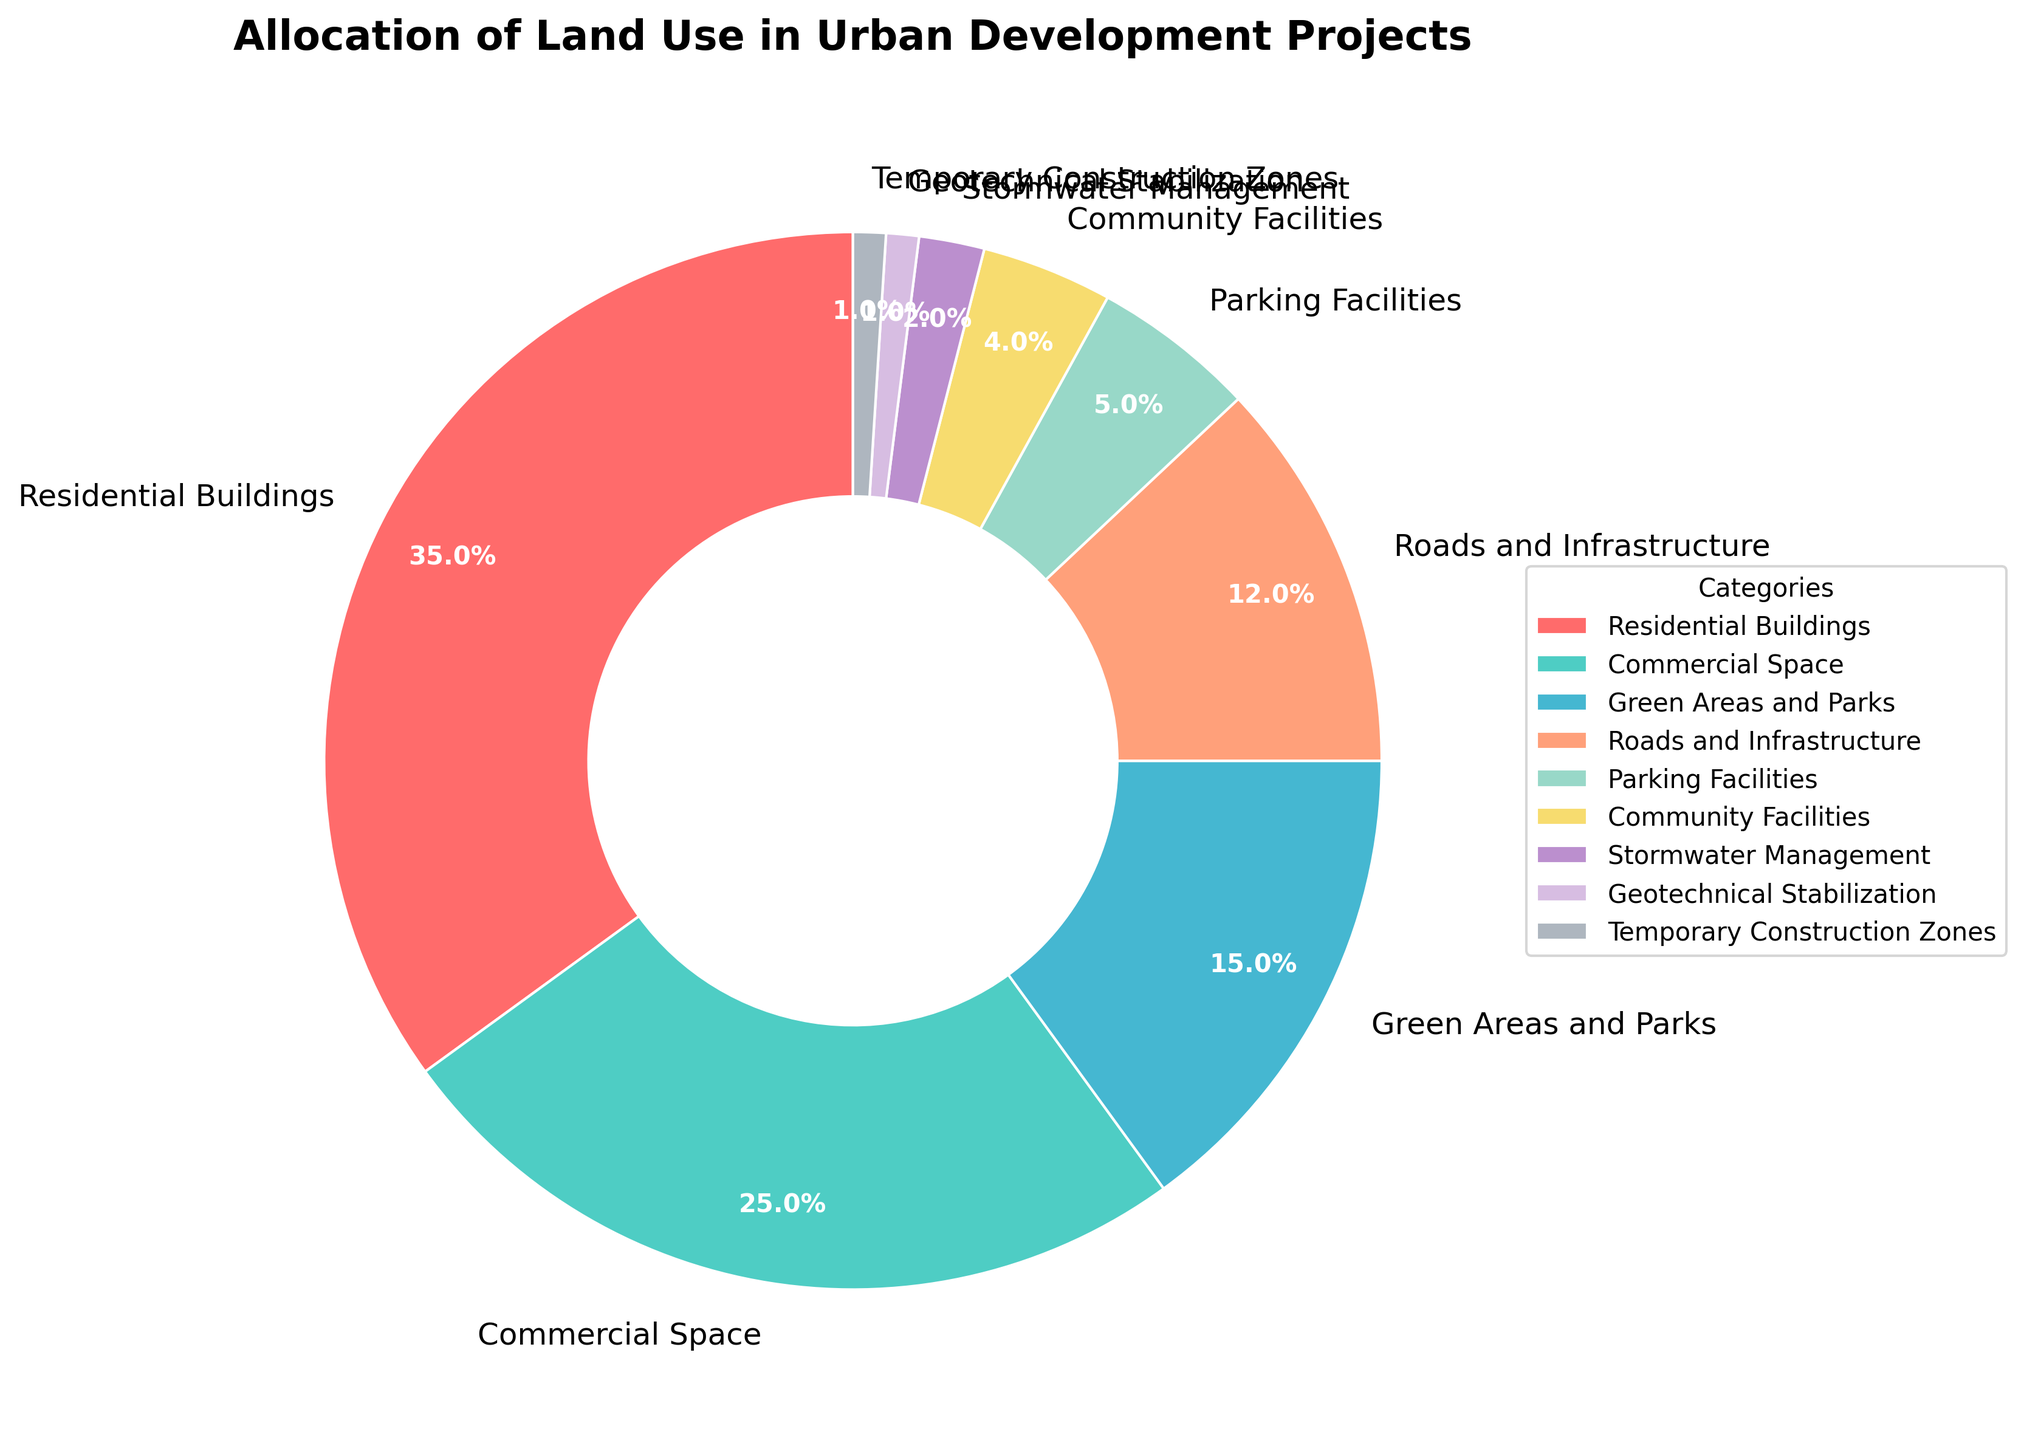What percentage of the land is used for Residential Buildings and Commercial Space combined? To find the total percentage used for Residential Buildings and Commercial Space, add their individual percentages: 35% (Residential Buildings) + 25% (Commercial Space) = 60%.
Answer: 60% Which category utilizes more land: Roads and Infrastructure or Green Areas and Parks? Compare the percentages: Roads and Infrastructure (12%) and Green Areas and Parks (15%). Since 15% is greater than 12%, Green Areas and Parks utilize more land.
Answer: Green Areas and Parks What is the proportion of land dedicated to Parking Facilities compared to Community Facilities? The proportion is found by dividing the percentage of land for Parking Facilities by the percentage for Community Facilities: 5% / 4% = 1.25. This means Parking Facilities use 1.25 times more land than Community Facilities.
Answer: 1.25 How much more land is allocated to Residential Buildings than to Parking Facilities and Community Facilities combined? First, find the combined percentage for Parking Facilities and Community Facilities: 5% + 4% = 9%. Then subtract this from the percentage for Residential Buildings: 35% - 9% = 26%. Residential Buildings use 26% more land.
Answer: 26% Are there any categories that use exactly the same percentage of land? By checking the list of categories and their respective percentages, Geotechnical Stabilization and Temporary Construction Zones both use 1% of the land, making them equal.
Answer: Yes Which category is associated with the dark green color? The dark green color on the pie chart corresponds to the Commercial Space category.
Answer: Commercial Space What is the total percentage of land used for Roads and Infrastructure, Parking Facilities, and Community Facilities? Sum the individual percentages: 12% (Roads and Infrastructure) + 5% (Parking Facilities) + 4% (Community Facilities) = 21%.
Answer: 21% Which category uses the least land, and what is its percentage? Geotechnical Stabilization and Temporary Construction Zones are tied for the least land use, each using 1%.
Answer: Geotechnical Stabilization and Temporary Construction Zones, 1% What is the difference in land allocation between Residential Buildings and all forms of infrastructure combined (Roads and Infrastructure, Parking Facilities, and Stormwater Management)? Calculate the total percentage for infrastructure: 12% (Roads and Infrastructure) + 5% (Parking Facilities) + 2% (Stormwater Management) = 19%. Then find the difference: 35% (Residential Buildings) - 19% (Infrastructure) = 16%.
Answer: 16% How much more land is allocated to Green Areas and Parks compared to Stormwater Management and Geotechnical Stabilization combined? First, add the percentages for Stormwater Management and Geotechnical Stabilization: 2% + 1% = 3%. Then subtract this from the percentage for Green Areas and Parks: 15% - 3% = 12%. Green Areas and Parks use 12% more land.
Answer: 12% 